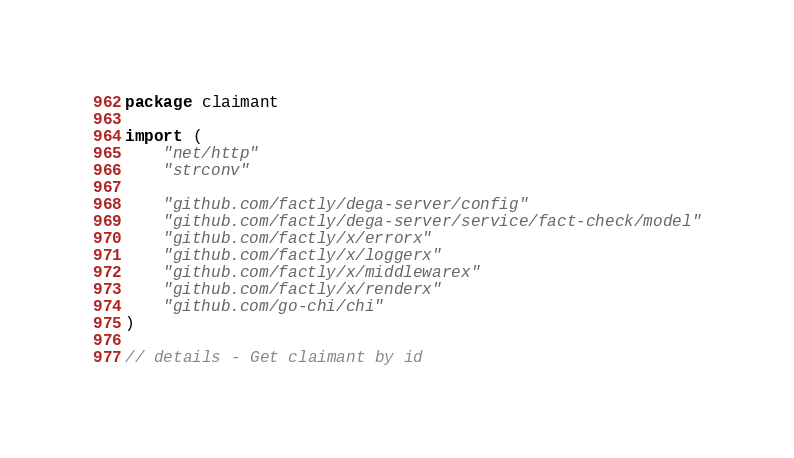<code> <loc_0><loc_0><loc_500><loc_500><_Go_>package claimant

import (
	"net/http"
	"strconv"

	"github.com/factly/dega-server/config"
	"github.com/factly/dega-server/service/fact-check/model"
	"github.com/factly/x/errorx"
	"github.com/factly/x/loggerx"
	"github.com/factly/x/middlewarex"
	"github.com/factly/x/renderx"
	"github.com/go-chi/chi"
)

// details - Get claimant by id</code> 